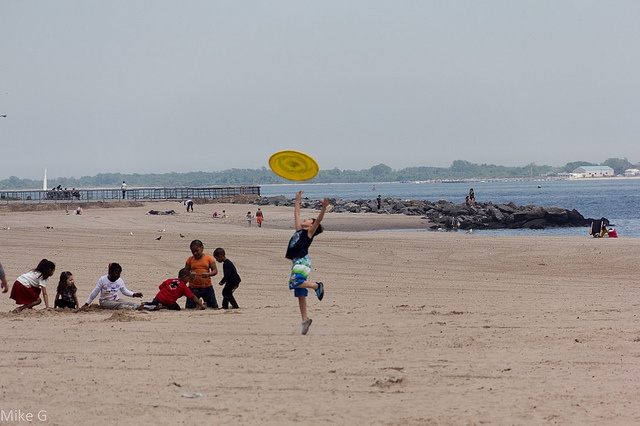Describe the objects in this image and their specific colors. I can see people in darkgray, black, and gray tones, people in darkgray, black, gray, and maroon tones, people in darkgray, black, maroon, and brown tones, people in darkgray, black, maroon, and gray tones, and frisbee in darkgray, olive, and tan tones in this image. 